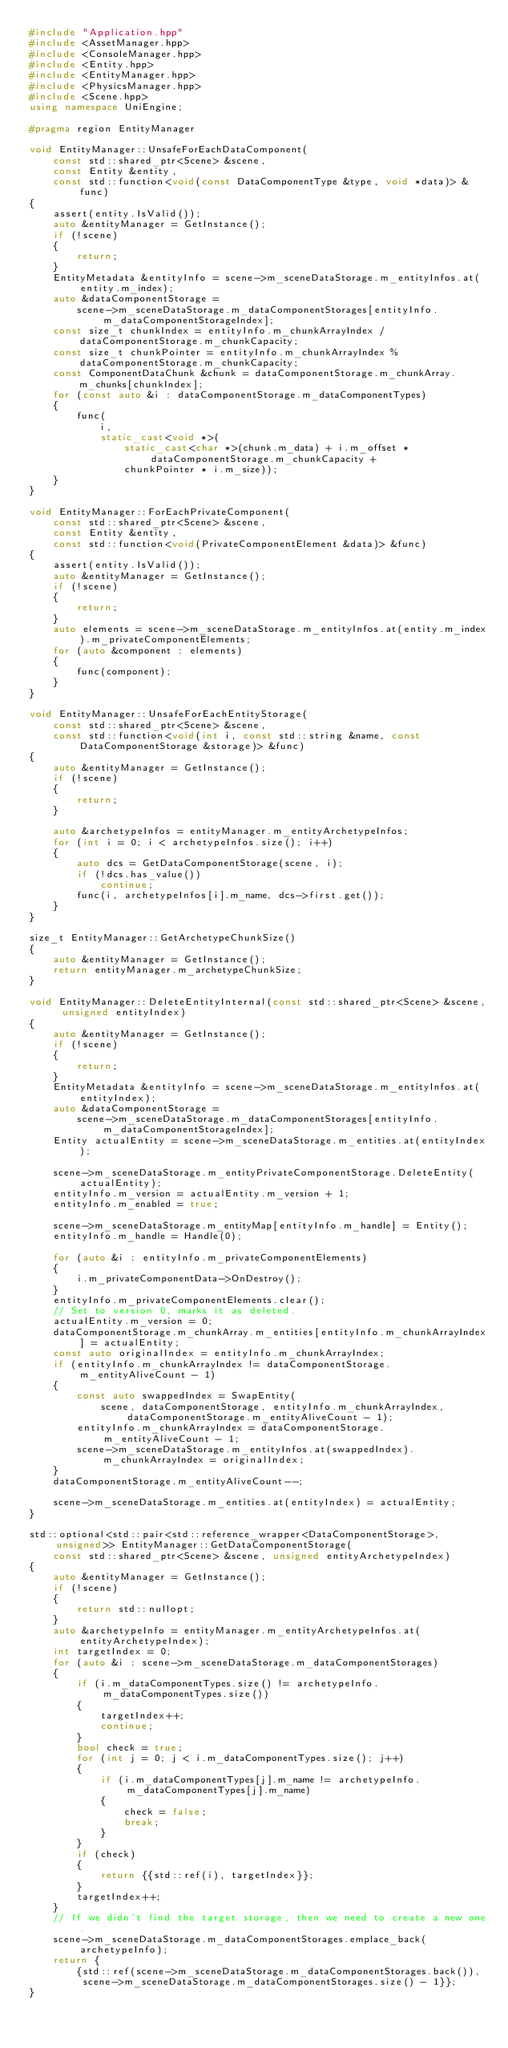<code> <loc_0><loc_0><loc_500><loc_500><_C++_>#include "Application.hpp"
#include <AssetManager.hpp>
#include <ConsoleManager.hpp>
#include <Entity.hpp>
#include <EntityManager.hpp>
#include <PhysicsManager.hpp>
#include <Scene.hpp>
using namespace UniEngine;

#pragma region EntityManager

void EntityManager::UnsafeForEachDataComponent(
    const std::shared_ptr<Scene> &scene,
    const Entity &entity,
    const std::function<void(const DataComponentType &type, void *data)> &func)
{
    assert(entity.IsValid());
    auto &entityManager = GetInstance();
    if (!scene)
    {
        return;
    }
    EntityMetadata &entityInfo = scene->m_sceneDataStorage.m_entityInfos.at(entity.m_index);
    auto &dataComponentStorage =
        scene->m_sceneDataStorage.m_dataComponentStorages[entityInfo.m_dataComponentStorageIndex];
    const size_t chunkIndex = entityInfo.m_chunkArrayIndex / dataComponentStorage.m_chunkCapacity;
    const size_t chunkPointer = entityInfo.m_chunkArrayIndex % dataComponentStorage.m_chunkCapacity;
    const ComponentDataChunk &chunk = dataComponentStorage.m_chunkArray.m_chunks[chunkIndex];
    for (const auto &i : dataComponentStorage.m_dataComponentTypes)
    {
        func(
            i,
            static_cast<void *>(
                static_cast<char *>(chunk.m_data) + i.m_offset * dataComponentStorage.m_chunkCapacity +
                chunkPointer * i.m_size));
    }
}

void EntityManager::ForEachPrivateComponent(
    const std::shared_ptr<Scene> &scene,
    const Entity &entity,
    const std::function<void(PrivateComponentElement &data)> &func)
{
    assert(entity.IsValid());
    auto &entityManager = GetInstance();
    if (!scene)
    {
        return;
    }
    auto elements = scene->m_sceneDataStorage.m_entityInfos.at(entity.m_index).m_privateComponentElements;
    for (auto &component : elements)
    {
        func(component);
    }
}

void EntityManager::UnsafeForEachEntityStorage(
    const std::shared_ptr<Scene> &scene,
    const std::function<void(int i, const std::string &name, const DataComponentStorage &storage)> &func)
{
    auto &entityManager = GetInstance();
    if (!scene)
    {
        return;
    }

    auto &archetypeInfos = entityManager.m_entityArchetypeInfos;
    for (int i = 0; i < archetypeInfos.size(); i++)
    {
        auto dcs = GetDataComponentStorage(scene, i);
        if (!dcs.has_value())
            continue;
        func(i, archetypeInfos[i].m_name, dcs->first.get());
    }
}

size_t EntityManager::GetArchetypeChunkSize()
{
    auto &entityManager = GetInstance();
    return entityManager.m_archetypeChunkSize;
}

void EntityManager::DeleteEntityInternal(const std::shared_ptr<Scene> &scene, unsigned entityIndex)
{
    auto &entityManager = GetInstance();
    if (!scene)
    {
        return;
    }
    EntityMetadata &entityInfo = scene->m_sceneDataStorage.m_entityInfos.at(entityIndex);
    auto &dataComponentStorage =
        scene->m_sceneDataStorage.m_dataComponentStorages[entityInfo.m_dataComponentStorageIndex];
    Entity actualEntity = scene->m_sceneDataStorage.m_entities.at(entityIndex);

    scene->m_sceneDataStorage.m_entityPrivateComponentStorage.DeleteEntity(actualEntity);
    entityInfo.m_version = actualEntity.m_version + 1;
    entityInfo.m_enabled = true;

    scene->m_sceneDataStorage.m_entityMap[entityInfo.m_handle] = Entity();
    entityInfo.m_handle = Handle(0);

    for (auto &i : entityInfo.m_privateComponentElements)
    {
        i.m_privateComponentData->OnDestroy();
    }
    entityInfo.m_privateComponentElements.clear();
    // Set to version 0, marks it as deleted.
    actualEntity.m_version = 0;
    dataComponentStorage.m_chunkArray.m_entities[entityInfo.m_chunkArrayIndex] = actualEntity;
    const auto originalIndex = entityInfo.m_chunkArrayIndex;
    if (entityInfo.m_chunkArrayIndex != dataComponentStorage.m_entityAliveCount - 1)
    {
        const auto swappedIndex = SwapEntity(
            scene, dataComponentStorage, entityInfo.m_chunkArrayIndex, dataComponentStorage.m_entityAliveCount - 1);
        entityInfo.m_chunkArrayIndex = dataComponentStorage.m_entityAliveCount - 1;
        scene->m_sceneDataStorage.m_entityInfos.at(swappedIndex).m_chunkArrayIndex = originalIndex;
    }
    dataComponentStorage.m_entityAliveCount--;

    scene->m_sceneDataStorage.m_entities.at(entityIndex) = actualEntity;
}

std::optional<std::pair<std::reference_wrapper<DataComponentStorage>, unsigned>> EntityManager::GetDataComponentStorage(
    const std::shared_ptr<Scene> &scene, unsigned entityArchetypeIndex)
{
    auto &entityManager = GetInstance();
    if (!scene)
    {
        return std::nullopt;
    }
    auto &archetypeInfo = entityManager.m_entityArchetypeInfos.at(entityArchetypeIndex);
    int targetIndex = 0;
    for (auto &i : scene->m_sceneDataStorage.m_dataComponentStorages)
    {
        if (i.m_dataComponentTypes.size() != archetypeInfo.m_dataComponentTypes.size())
        {
            targetIndex++;
            continue;
        }
        bool check = true;
        for (int j = 0; j < i.m_dataComponentTypes.size(); j++)
        {
            if (i.m_dataComponentTypes[j].m_name != archetypeInfo.m_dataComponentTypes[j].m_name)
            {
                check = false;
                break;
            }
        }
        if (check)
        {
            return {{std::ref(i), targetIndex}};
        }
        targetIndex++;
    }
    // If we didn't find the target storage, then we need to create a new one.
    scene->m_sceneDataStorage.m_dataComponentStorages.emplace_back(archetypeInfo);
    return {
        {std::ref(scene->m_sceneDataStorage.m_dataComponentStorages.back()),
         scene->m_sceneDataStorage.m_dataComponentStorages.size() - 1}};
}
</code> 